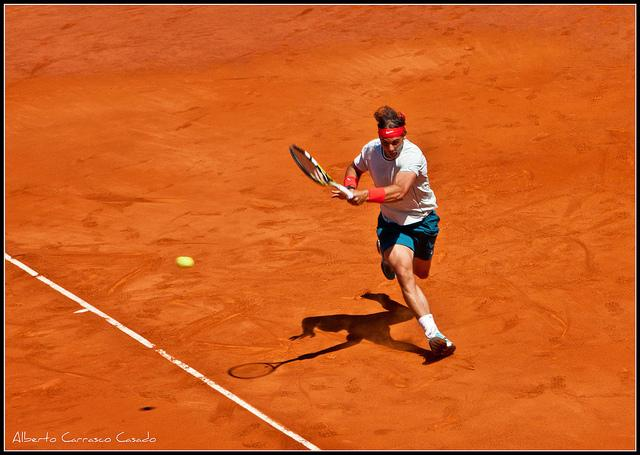Upon what surfaced court is this game being played?

Choices:
A) asphalt
B) concrete
C) grass
D) clay clay 